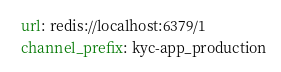<code> <loc_0><loc_0><loc_500><loc_500><_YAML_>  url: redis://localhost:6379/1
  channel_prefix: kyc-app_production
</code> 